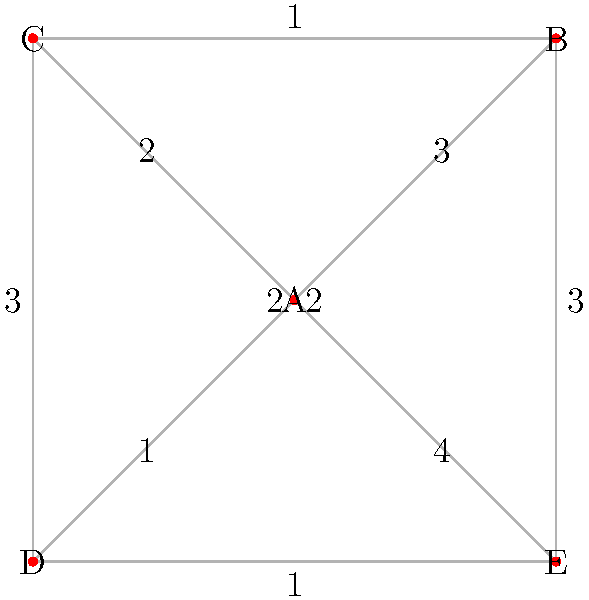In the early Roman Republic, a network diagram represents voting patterns among five influential senators (A, B, C, D, E). The weight of each edge indicates the frequency of agreement between two senators. What is the minimum number of senators needed to form a voting bloc that can influence at least 60% of the total voting agreements? To solve this problem, we need to follow these steps:

1. Calculate the total number of voting agreements:
   Sum of all edge weights = 3 + 2 + 1 + 4 + 1 + 2 + 3 + 3 + 2 + 1 = 22

2. Calculate 60% of the total voting agreements:
   60% of 22 = 0.6 × 22 = 13.2
   We need to round up to 14 since we can't have fractional agreements.

3. Find the minimum number of senators needed to reach 14 agreements:
   a) Start with the senator with the highest total agreements:
      A: 3 + 2 + 1 + 4 = 10
      B: 3 + 1 + 2 + 3 = 9
      C: 2 + 1 + 3 + 2 = 8
      D: 1 + 2 + 3 + 1 = 7
      E: 4 + 3 + 2 + 1 = 10
   
   b) Senator A or E has the highest with 10 agreements.

   c) We need 4 more agreements to reach 14. The next highest connection is:
      A-B or A-E with 3 agreements.

   d) Adding either B or E to A gives us 13 agreements, which is still short by 1.

   e) We need to add one more senator to reach at least 14 agreements.

Therefore, the minimum number of senators needed is 3.
Answer: 3 senators 